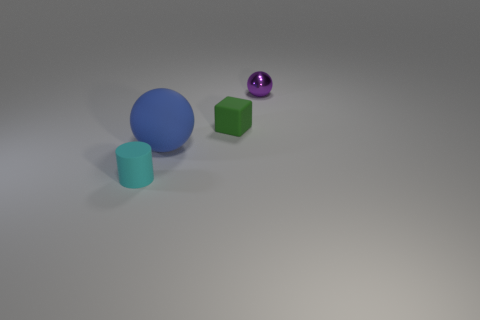Are there any other things that are the same size as the blue matte ball?
Keep it short and to the point. No. Is there any other thing that has the same material as the small purple thing?
Ensure brevity in your answer.  No. What number of rubber things are on the right side of the small cyan matte cylinder and to the left of the small green rubber block?
Provide a short and direct response. 1. How many other objects are the same size as the metal object?
Your answer should be very brief. 2. There is a thing behind the green matte thing; is its shape the same as the large thing in front of the small green object?
Make the answer very short. Yes. How many objects are purple shiny spheres or spheres behind the tiny matte cube?
Your response must be concise. 1. What material is the thing that is to the left of the small ball and behind the large matte thing?
Provide a short and direct response. Rubber. Is there anything else that is the same shape as the big blue rubber object?
Make the answer very short. Yes. What is the color of the block that is made of the same material as the tiny cyan cylinder?
Make the answer very short. Green. How many things are green blocks or cyan rubber cylinders?
Offer a terse response. 2. 